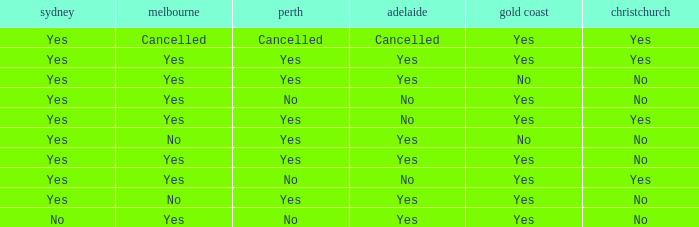What is The Melbourne with a No- Gold Coast Yes, No. 